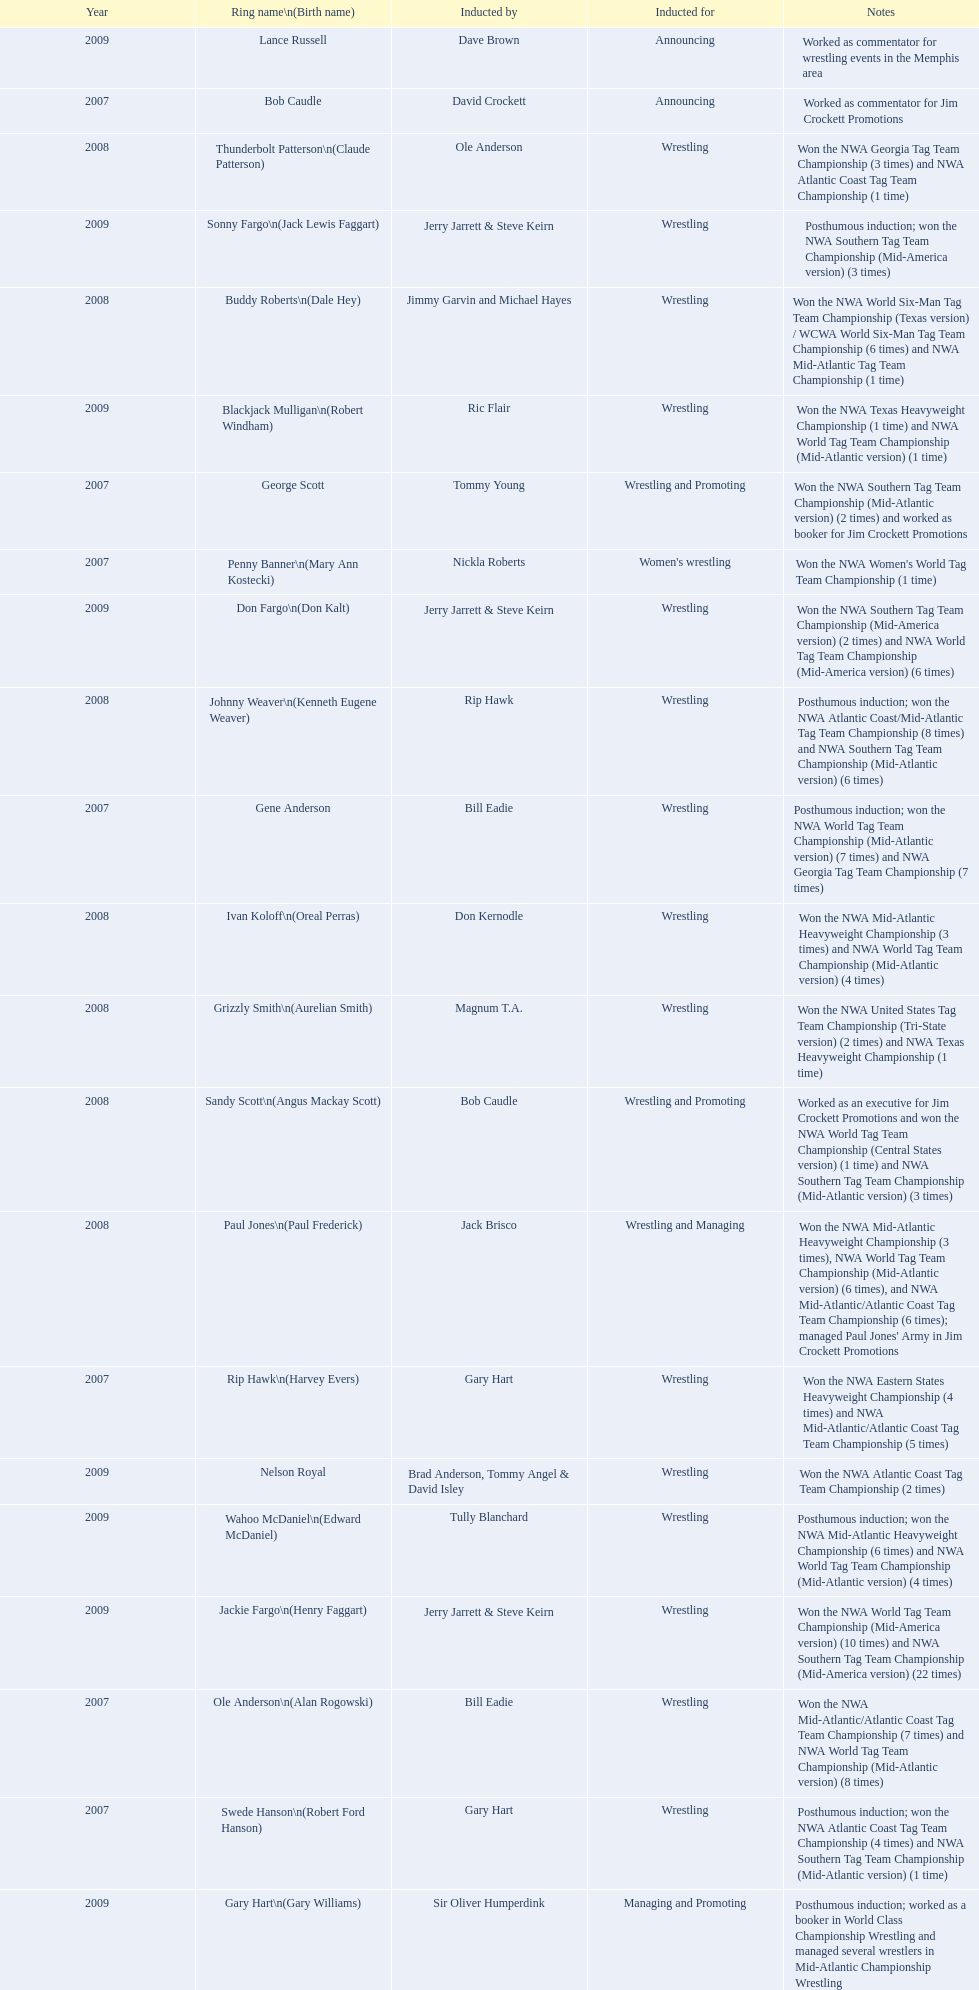What year was the induction held? 2007. Which inductee was not alive? Gene Anderson. 